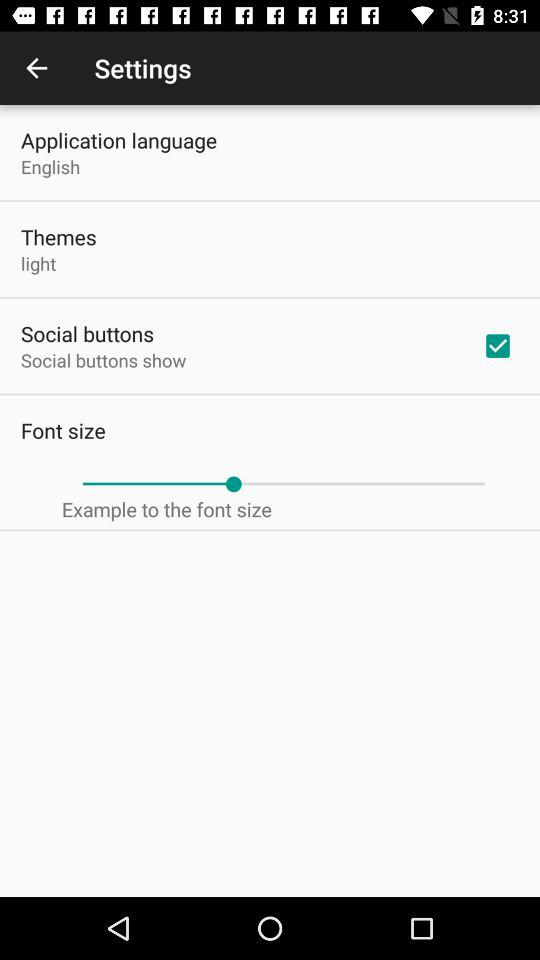Is Italian on the list of application languages?
When the provided information is insufficient, respond with <no answer>. <no answer> 